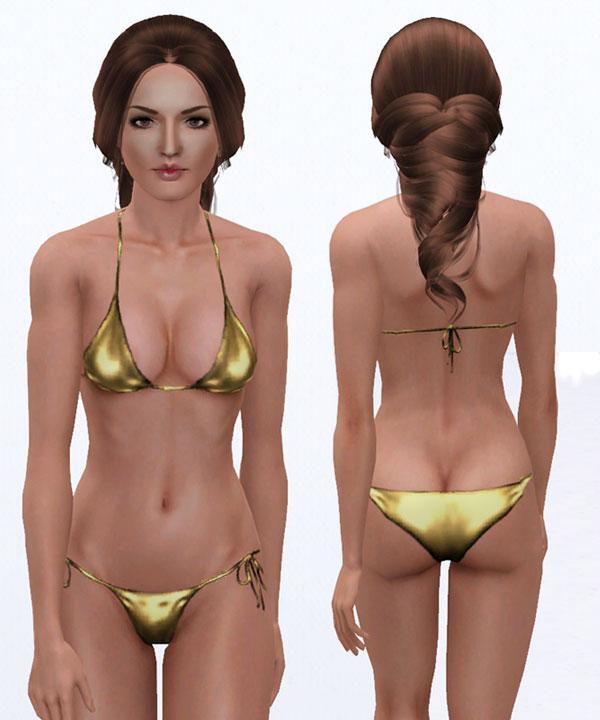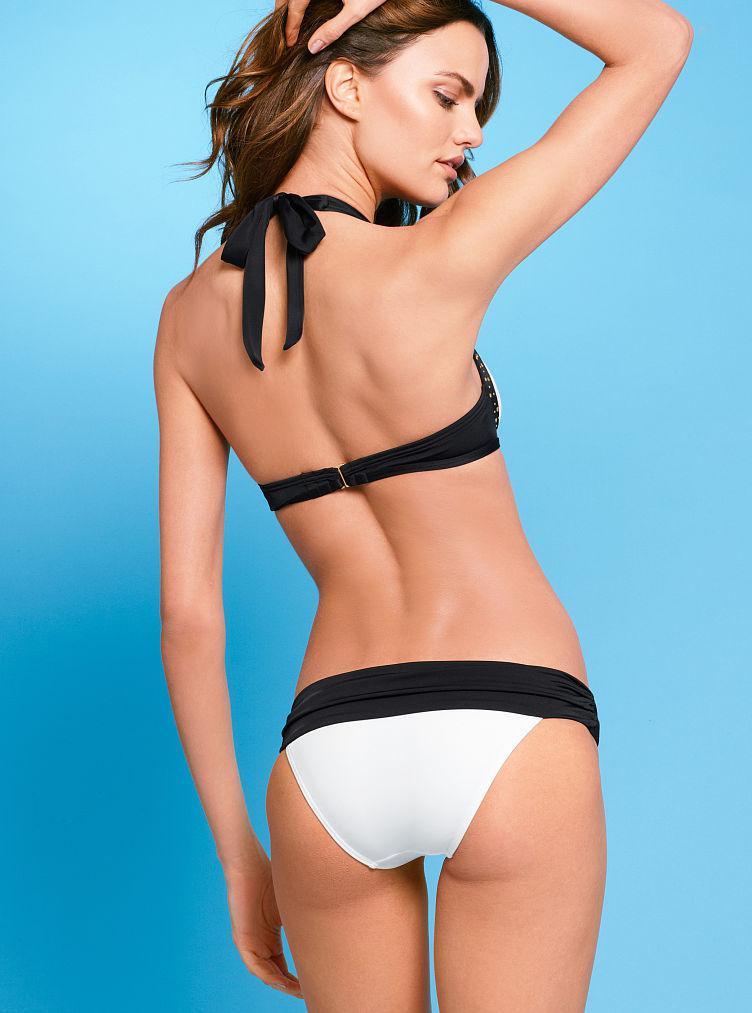The first image is the image on the left, the second image is the image on the right. Analyze the images presented: Is the assertion "In the left image, the bikini is black." valid? Answer yes or no. No. The first image is the image on the left, the second image is the image on the right. Analyze the images presented: Is the assertion "There is exactly one woman in a swimsuit in each image." valid? Answer yes or no. No. 